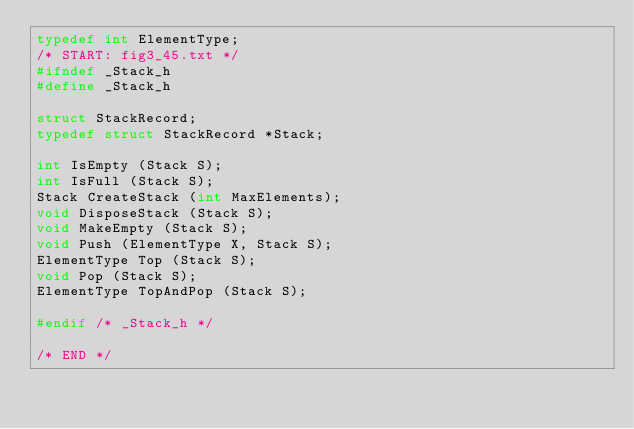<code> <loc_0><loc_0><loc_500><loc_500><_C_>typedef int ElementType;
/* START: fig3_45.txt */
#ifndef _Stack_h
#define _Stack_h

struct StackRecord;
typedef struct StackRecord *Stack;

int IsEmpty (Stack S);
int IsFull (Stack S);
Stack CreateStack (int MaxElements);
void DisposeStack (Stack S);
void MakeEmpty (Stack S);
void Push (ElementType X, Stack S);
ElementType Top (Stack S);
void Pop (Stack S);
ElementType TopAndPop (Stack S);

#endif /* _Stack_h */

/* END */
</code> 